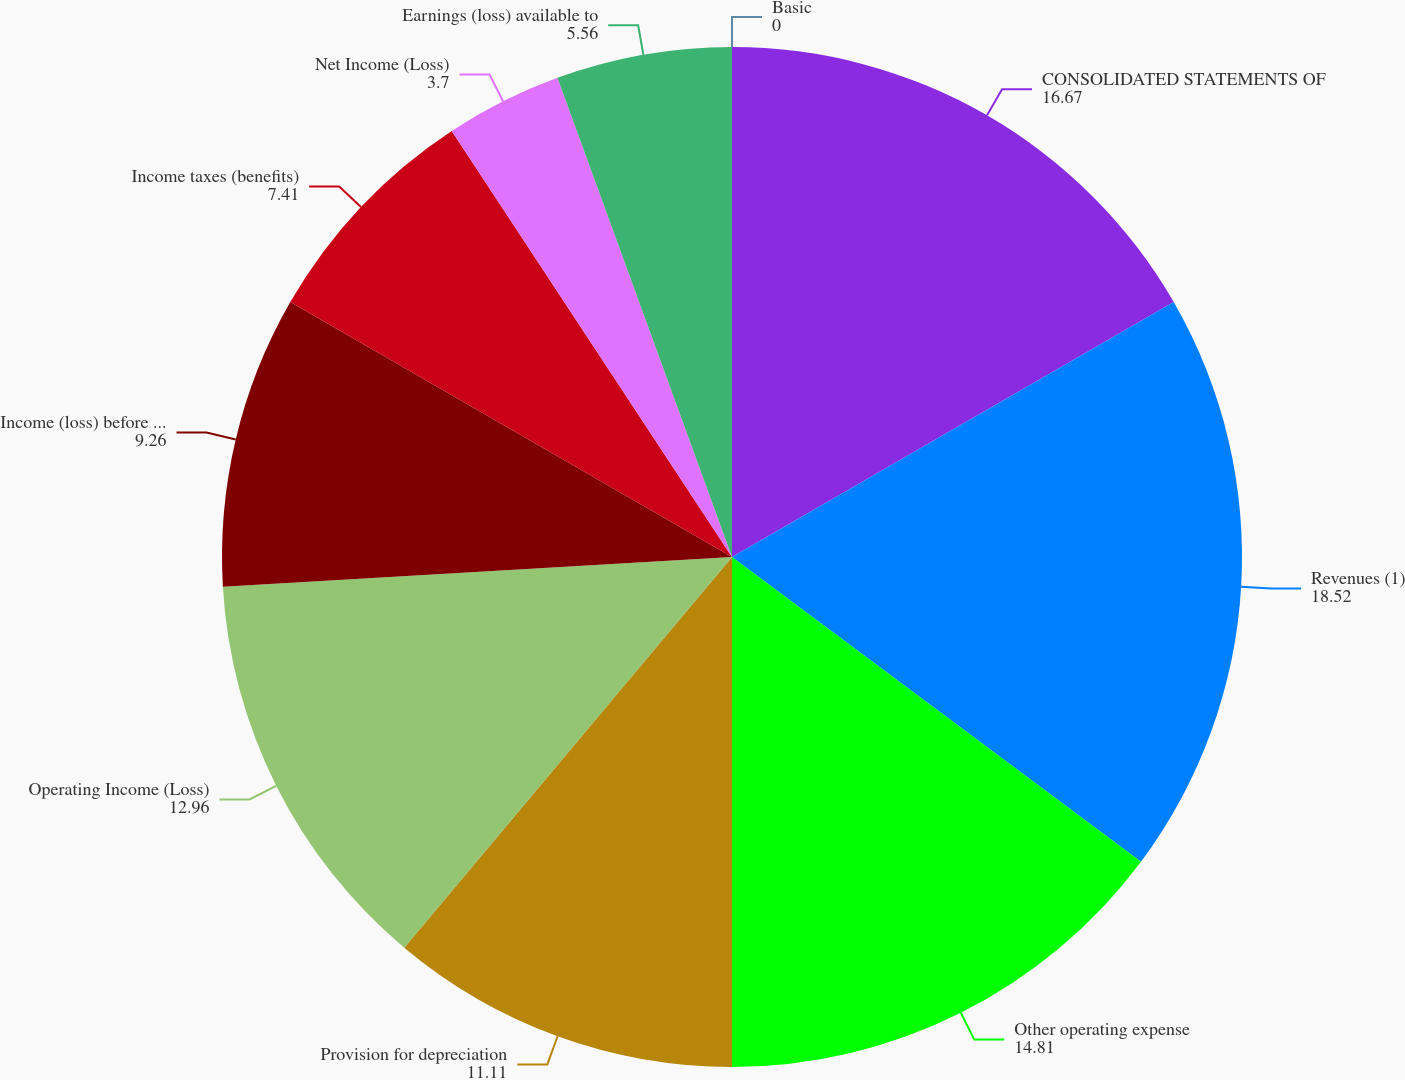Convert chart to OTSL. <chart><loc_0><loc_0><loc_500><loc_500><pie_chart><fcel>CONSOLIDATED STATEMENTS OF<fcel>Revenues (1)<fcel>Other operating expense<fcel>Provision for depreciation<fcel>Operating Income (Loss)<fcel>Income (loss) before income<fcel>Income taxes (benefits)<fcel>Net Income (Loss)<fcel>Earnings (loss) available to<fcel>Basic<nl><fcel>16.67%<fcel>18.52%<fcel>14.81%<fcel>11.11%<fcel>12.96%<fcel>9.26%<fcel>7.41%<fcel>3.7%<fcel>5.56%<fcel>0.0%<nl></chart> 